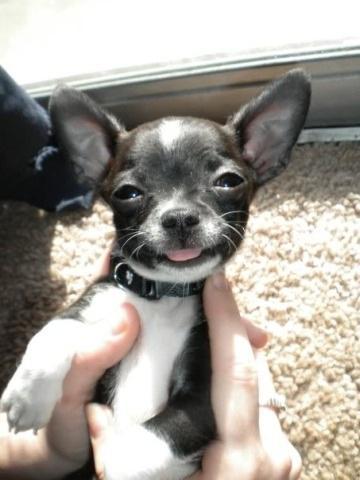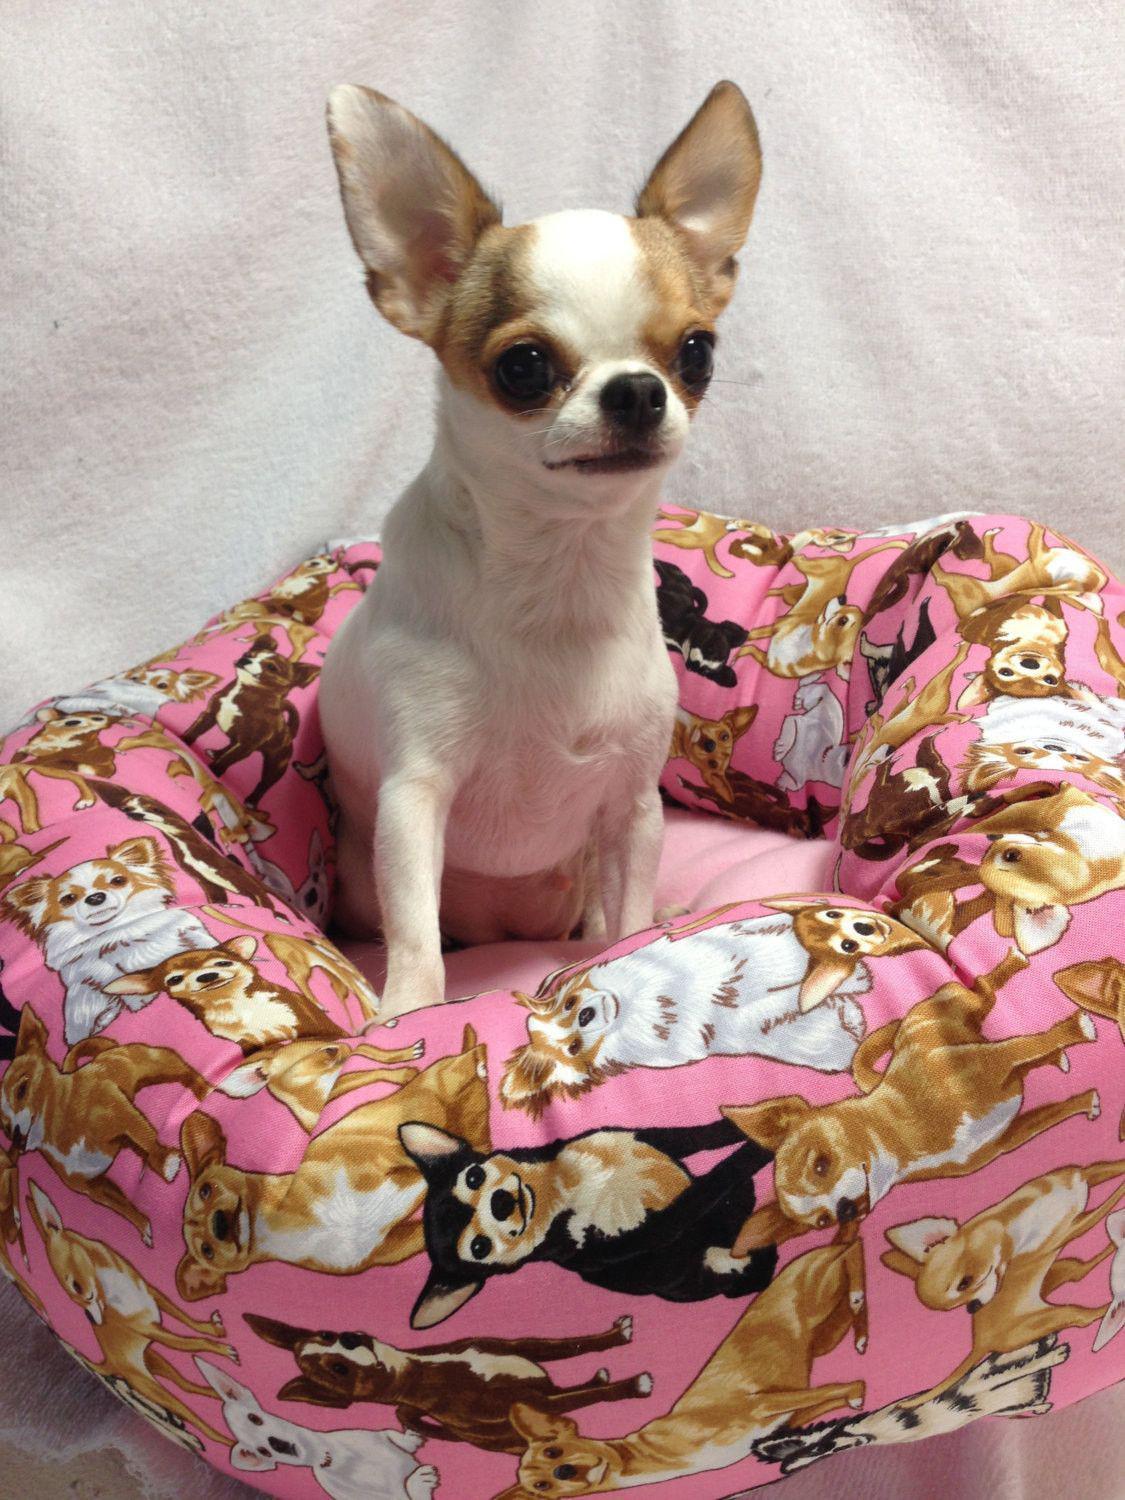The first image is the image on the left, the second image is the image on the right. Examine the images to the left and right. Is the description "Only one image shows dogs wearing some kind of attire besides an ordinary dog collar." accurate? Answer yes or no. No. The first image is the image on the left, the second image is the image on the right. Assess this claim about the two images: "An image shows exactly two dogs wearing fancy garb.". Correct or not? Answer yes or no. No. The first image is the image on the left, the second image is the image on the right. Assess this claim about the two images: "One of the images shows exactly two dogs.". Correct or not? Answer yes or no. No. 